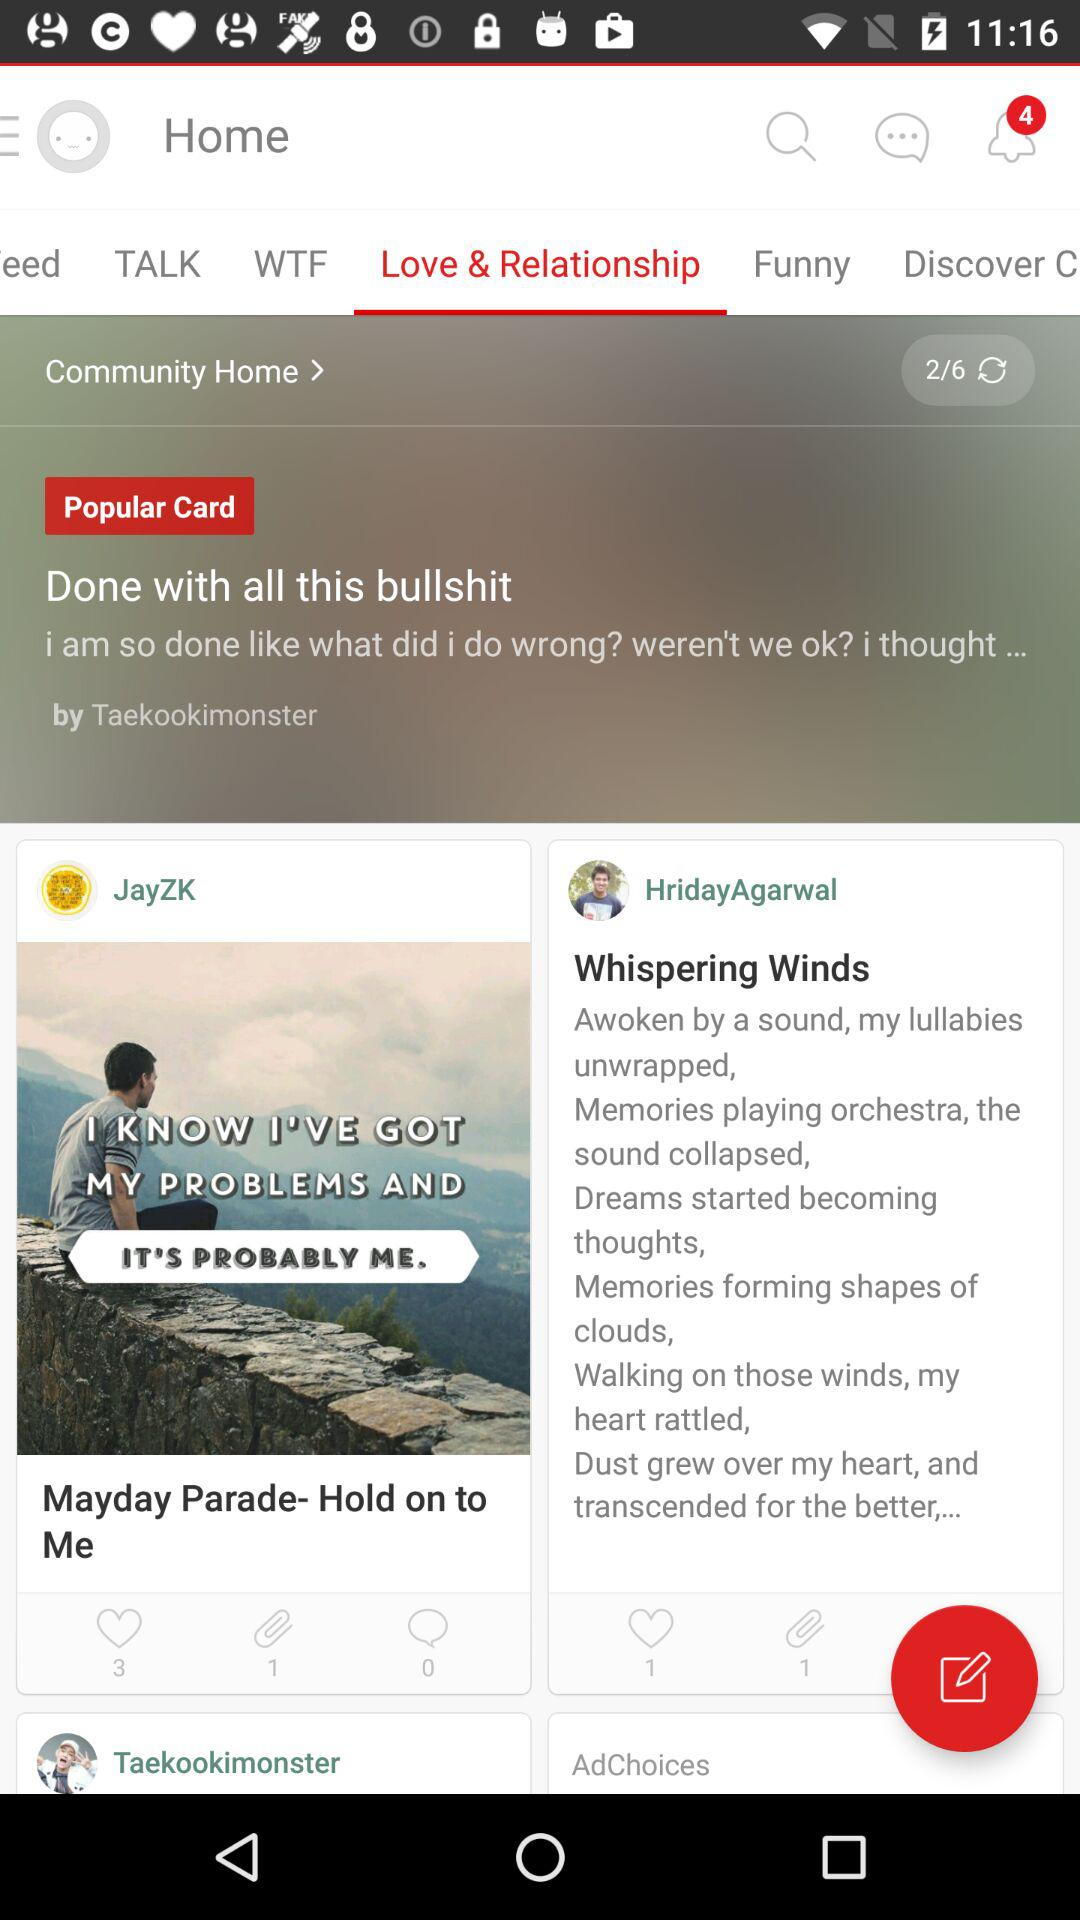How many more hearts does the top post have than the second post?
Answer the question using a single word or phrase. 2 